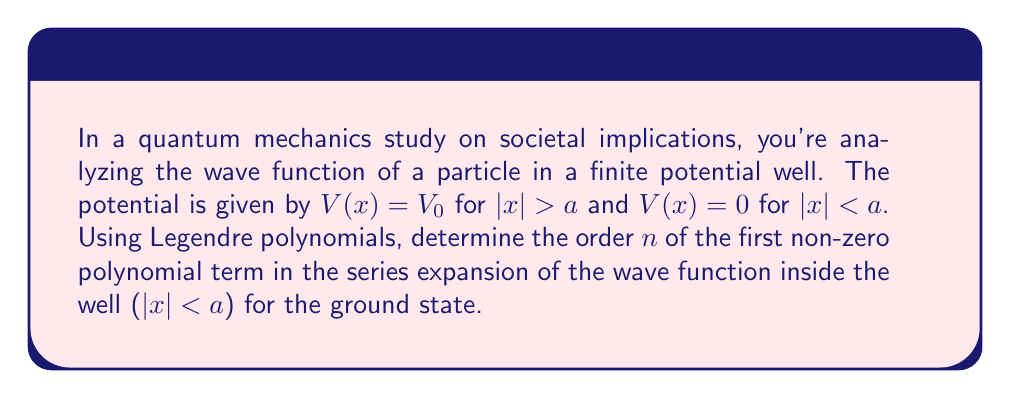Provide a solution to this math problem. 1) The general solution for the wave function inside the well ($|x| < a$) can be expressed as a series of Legendre polynomials:

   $$\psi(x) = \sum_{n=0}^{\infty} A_n P_n(x/a)$$

   where $P_n(x/a)$ are Legendre polynomials and $A_n$ are coefficients.

2) The ground state wave function must be symmetric (even) about $x = 0$. This means only even-order Legendre polynomials will contribute.

3) Legendre polynomials have the following parity property:
   
   $$P_n(-x) = (-1)^n P_n(x)$$

4) For even functions, we need $n$ to be even. The first even Legendre polynomial is $P_0(x) = 1$.

5) However, $P_0(x)$ doesn't satisfy the boundary condition that the wave function must go to zero at the edges of the well ($x = \pm a$).

6) The next even Legendre polynomial is $P_2(x) = \frac{1}{2}(3x^2 - 1)$.

7) $P_2(x)$ can satisfy the boundary conditions and is the first non-constant term that can contribute to the ground state wave function.

Therefore, the first non-zero term in the series expansion (after the constant term) will be of order $n = 2$.
Answer: $n = 2$ 